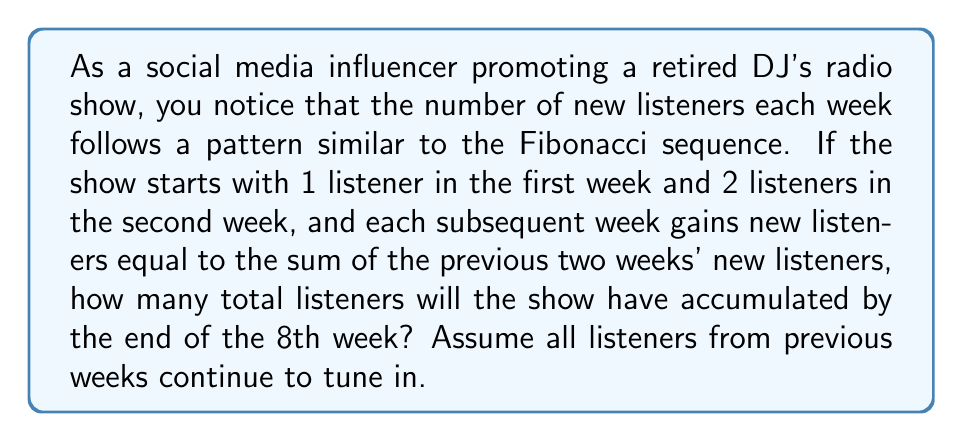What is the answer to this math problem? Let's approach this step-by-step using the Fibonacci sequence:

1) First, let's recall the Fibonacci sequence: 
   $F_n = F_{n-1} + F_{n-2}$, where $F_1 = 1$ and $F_2 = 2$

2) The number of new listeners each week follows this sequence:
   Week 1: 1
   Week 2: 2
   Week 3: 3 (1 + 2)
   Week 4: 5 (2 + 3)
   Week 5: 8 (3 + 5)
   Week 6: 13 (5 + 8)
   Week 7: 21 (8 + 13)
   Week 8: 34 (13 + 21)

3) To find the total accumulated listeners, we need to sum these numbers:
   $\sum_{i=1}^8 F_i = 1 + 2 + 3 + 5 + 8 + 13 + 21 + 34$

4) There's a clever formula for the sum of Fibonacci numbers:
   $\sum_{i=1}^n F_i = F_{n+2} - 1$

5) In our case, $n = 8$, so we need to calculate $F_{10} - 1$:
   $F_9 = 34 + 21 = 55$
   $F_{10} = 55 + 34 = 89$

6) Therefore, the total number of accumulated listeners is:
   $F_{10} - 1 = 89 - 1 = 88$

This matches the sum we would get if we added up all the numbers manually.
Answer: The radio show will have accumulated a total of 88 listeners by the end of the 8th week. 